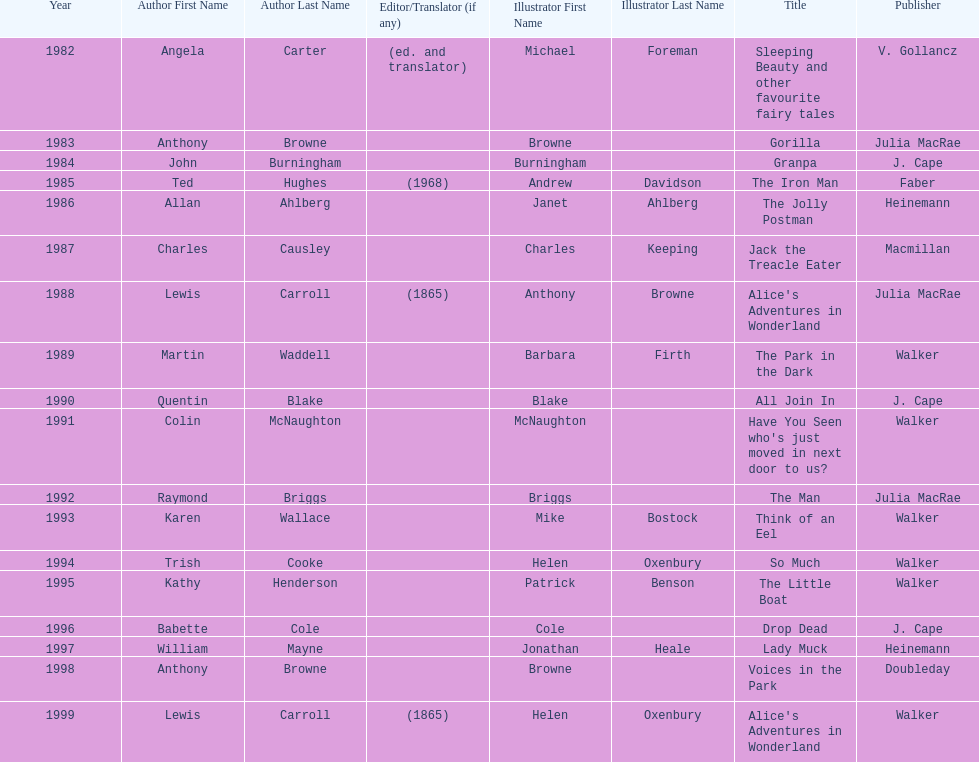Which illustrator was responsible for the last award winner? Helen Oxenbury. 